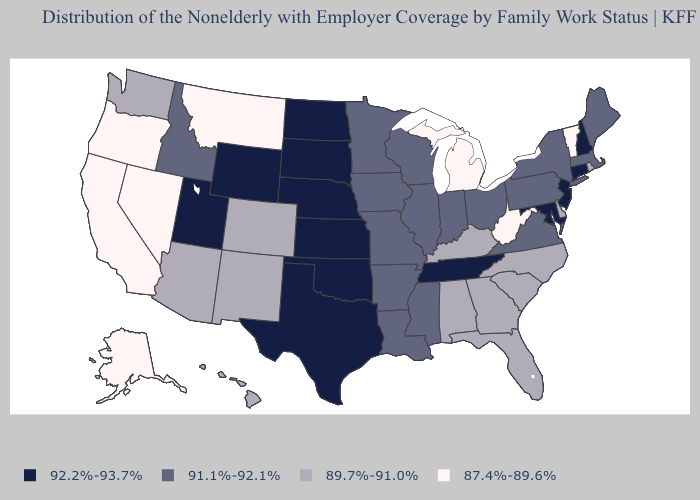What is the lowest value in states that border Colorado?
Give a very brief answer. 89.7%-91.0%. Does Louisiana have the lowest value in the South?
Answer briefly. No. What is the value of North Carolina?
Keep it brief. 89.7%-91.0%. What is the value of Arizona?
Write a very short answer. 89.7%-91.0%. Which states hav the highest value in the South?
Short answer required. Maryland, Oklahoma, Tennessee, Texas. Name the states that have a value in the range 92.2%-93.7%?
Concise answer only. Connecticut, Kansas, Maryland, Nebraska, New Hampshire, New Jersey, North Dakota, Oklahoma, South Dakota, Tennessee, Texas, Utah, Wyoming. Name the states that have a value in the range 89.7%-91.0%?
Concise answer only. Alabama, Arizona, Colorado, Delaware, Florida, Georgia, Hawaii, Kentucky, New Mexico, North Carolina, Rhode Island, South Carolina, Washington. Name the states that have a value in the range 92.2%-93.7%?
Be succinct. Connecticut, Kansas, Maryland, Nebraska, New Hampshire, New Jersey, North Dakota, Oklahoma, South Dakota, Tennessee, Texas, Utah, Wyoming. How many symbols are there in the legend?
Write a very short answer. 4. Name the states that have a value in the range 91.1%-92.1%?
Concise answer only. Arkansas, Idaho, Illinois, Indiana, Iowa, Louisiana, Maine, Massachusetts, Minnesota, Mississippi, Missouri, New York, Ohio, Pennsylvania, Virginia, Wisconsin. Among the states that border Arkansas , which have the highest value?
Keep it brief. Oklahoma, Tennessee, Texas. Name the states that have a value in the range 89.7%-91.0%?
Be succinct. Alabama, Arizona, Colorado, Delaware, Florida, Georgia, Hawaii, Kentucky, New Mexico, North Carolina, Rhode Island, South Carolina, Washington. What is the value of Ohio?
Short answer required. 91.1%-92.1%. Name the states that have a value in the range 89.7%-91.0%?
Keep it brief. Alabama, Arizona, Colorado, Delaware, Florida, Georgia, Hawaii, Kentucky, New Mexico, North Carolina, Rhode Island, South Carolina, Washington. 